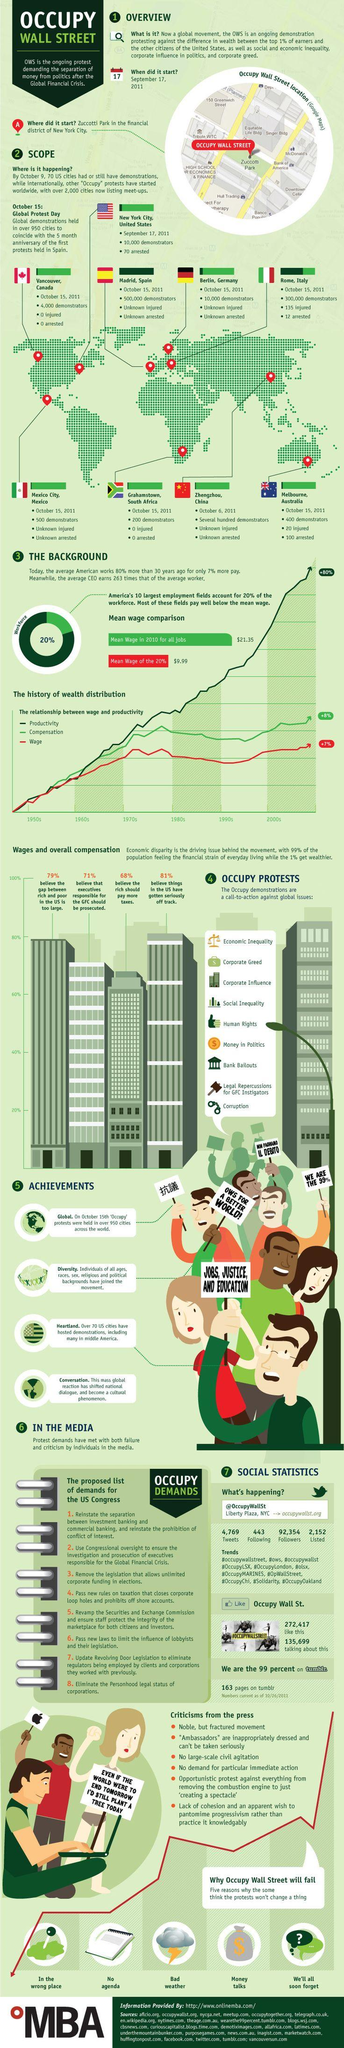Mention a couple of crucial points in this snapshot. On October 15, 2011, the city of Madrid, Spain had the highest number of protestors. Zhenghzhou, China was the city that had an unknown number of protestors. The building located towards the right of Zuccoti park is named Bank of America. There are at least 5 reasons that may contribute to the failure of the Occupy Wall Street movement. 